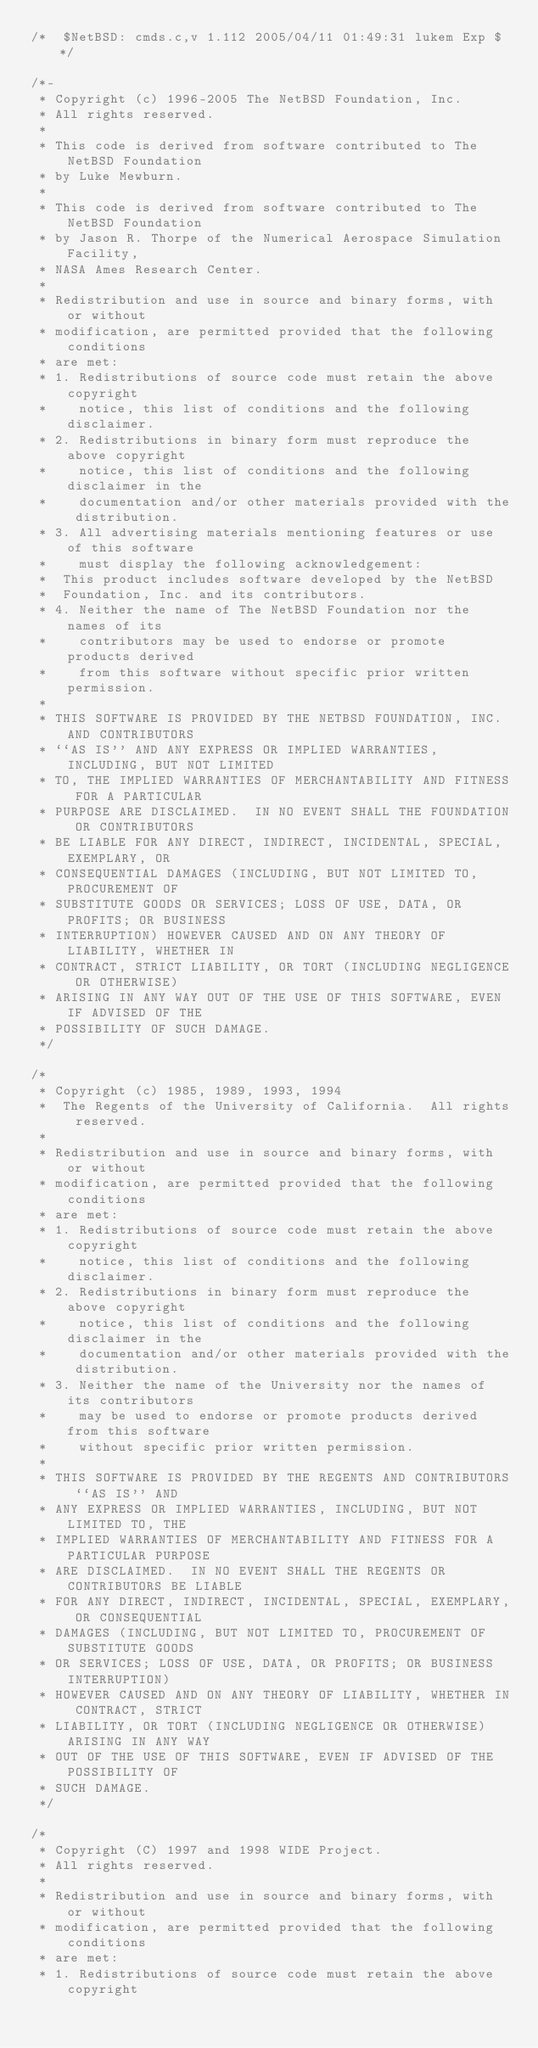Convert code to text. <code><loc_0><loc_0><loc_500><loc_500><_C_>/*	$NetBSD: cmds.c,v 1.112 2005/04/11 01:49:31 lukem Exp $	*/

/*-
 * Copyright (c) 1996-2005 The NetBSD Foundation, Inc.
 * All rights reserved.
 *
 * This code is derived from software contributed to The NetBSD Foundation
 * by Luke Mewburn.
 *
 * This code is derived from software contributed to The NetBSD Foundation
 * by Jason R. Thorpe of the Numerical Aerospace Simulation Facility,
 * NASA Ames Research Center.
 *
 * Redistribution and use in source and binary forms, with or without
 * modification, are permitted provided that the following conditions
 * are met:
 * 1. Redistributions of source code must retain the above copyright
 *    notice, this list of conditions and the following disclaimer.
 * 2. Redistributions in binary form must reproduce the above copyright
 *    notice, this list of conditions and the following disclaimer in the
 *    documentation and/or other materials provided with the distribution.
 * 3. All advertising materials mentioning features or use of this software
 *    must display the following acknowledgement:
 *	This product includes software developed by the NetBSD
 *	Foundation, Inc. and its contributors.
 * 4. Neither the name of The NetBSD Foundation nor the names of its
 *    contributors may be used to endorse or promote products derived
 *    from this software without specific prior written permission.
 *
 * THIS SOFTWARE IS PROVIDED BY THE NETBSD FOUNDATION, INC. AND CONTRIBUTORS
 * ``AS IS'' AND ANY EXPRESS OR IMPLIED WARRANTIES, INCLUDING, BUT NOT LIMITED
 * TO, THE IMPLIED WARRANTIES OF MERCHANTABILITY AND FITNESS FOR A PARTICULAR
 * PURPOSE ARE DISCLAIMED.  IN NO EVENT SHALL THE FOUNDATION OR CONTRIBUTORS
 * BE LIABLE FOR ANY DIRECT, INDIRECT, INCIDENTAL, SPECIAL, EXEMPLARY, OR
 * CONSEQUENTIAL DAMAGES (INCLUDING, BUT NOT LIMITED TO, PROCUREMENT OF
 * SUBSTITUTE GOODS OR SERVICES; LOSS OF USE, DATA, OR PROFITS; OR BUSINESS
 * INTERRUPTION) HOWEVER CAUSED AND ON ANY THEORY OF LIABILITY, WHETHER IN
 * CONTRACT, STRICT LIABILITY, OR TORT (INCLUDING NEGLIGENCE OR OTHERWISE)
 * ARISING IN ANY WAY OUT OF THE USE OF THIS SOFTWARE, EVEN IF ADVISED OF THE
 * POSSIBILITY OF SUCH DAMAGE.
 */

/*
 * Copyright (c) 1985, 1989, 1993, 1994
 *	The Regents of the University of California.  All rights reserved.
 *
 * Redistribution and use in source and binary forms, with or without
 * modification, are permitted provided that the following conditions
 * are met:
 * 1. Redistributions of source code must retain the above copyright
 *    notice, this list of conditions and the following disclaimer.
 * 2. Redistributions in binary form must reproduce the above copyright
 *    notice, this list of conditions and the following disclaimer in the
 *    documentation and/or other materials provided with the distribution.
 * 3. Neither the name of the University nor the names of its contributors
 *    may be used to endorse or promote products derived from this software
 *    without specific prior written permission.
 *
 * THIS SOFTWARE IS PROVIDED BY THE REGENTS AND CONTRIBUTORS ``AS IS'' AND
 * ANY EXPRESS OR IMPLIED WARRANTIES, INCLUDING, BUT NOT LIMITED TO, THE
 * IMPLIED WARRANTIES OF MERCHANTABILITY AND FITNESS FOR A PARTICULAR PURPOSE
 * ARE DISCLAIMED.  IN NO EVENT SHALL THE REGENTS OR CONTRIBUTORS BE LIABLE
 * FOR ANY DIRECT, INDIRECT, INCIDENTAL, SPECIAL, EXEMPLARY, OR CONSEQUENTIAL
 * DAMAGES (INCLUDING, BUT NOT LIMITED TO, PROCUREMENT OF SUBSTITUTE GOODS
 * OR SERVICES; LOSS OF USE, DATA, OR PROFITS; OR BUSINESS INTERRUPTION)
 * HOWEVER CAUSED AND ON ANY THEORY OF LIABILITY, WHETHER IN CONTRACT, STRICT
 * LIABILITY, OR TORT (INCLUDING NEGLIGENCE OR OTHERWISE) ARISING IN ANY WAY
 * OUT OF THE USE OF THIS SOFTWARE, EVEN IF ADVISED OF THE POSSIBILITY OF
 * SUCH DAMAGE.
 */

/*
 * Copyright (C) 1997 and 1998 WIDE Project.
 * All rights reserved.
 *
 * Redistribution and use in source and binary forms, with or without
 * modification, are permitted provided that the following conditions
 * are met:
 * 1. Redistributions of source code must retain the above copyright</code> 